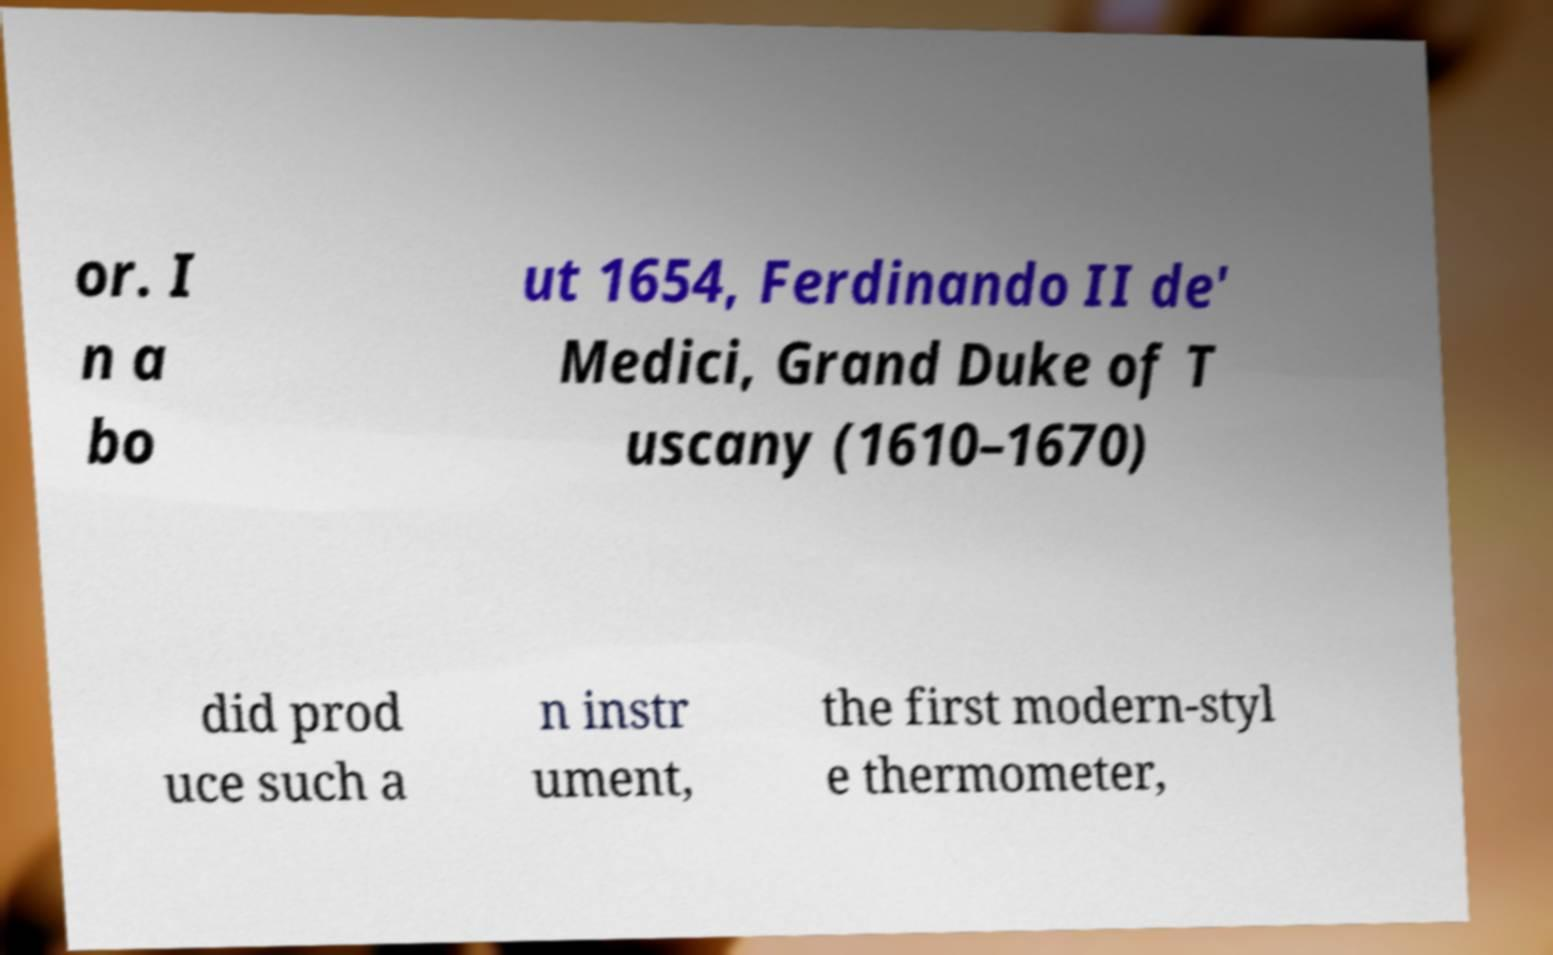There's text embedded in this image that I need extracted. Can you transcribe it verbatim? or. I n a bo ut 1654, Ferdinando II de' Medici, Grand Duke of T uscany (1610–1670) did prod uce such a n instr ument, the first modern-styl e thermometer, 